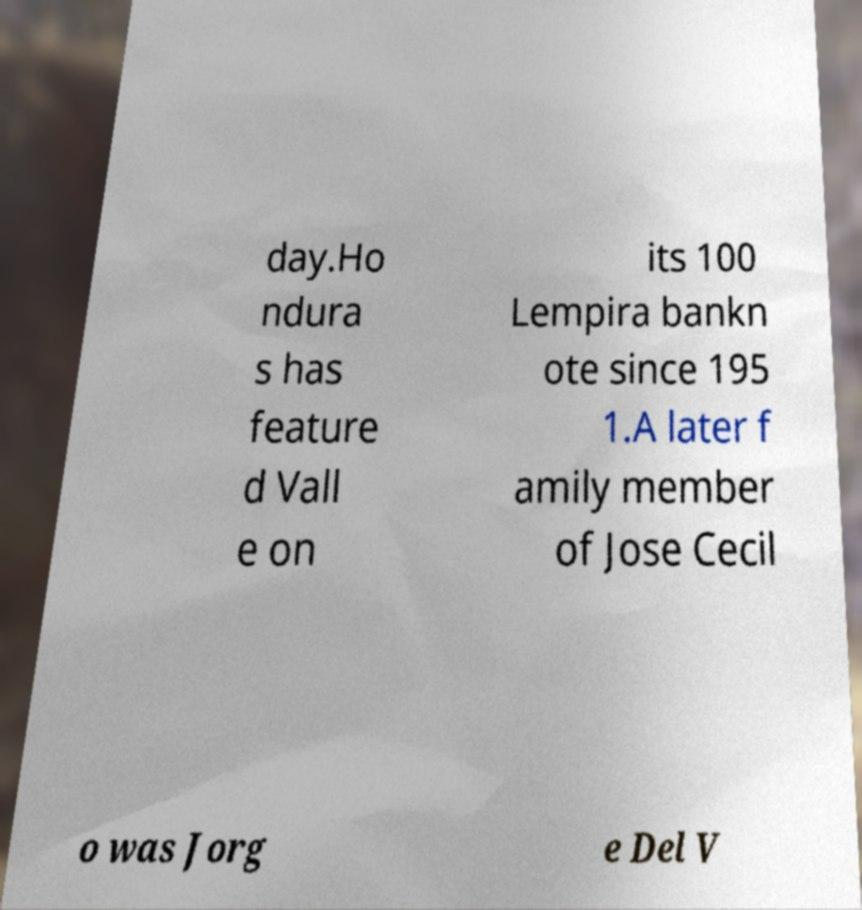Can you read and provide the text displayed in the image?This photo seems to have some interesting text. Can you extract and type it out for me? day.Ho ndura s has feature d Vall e on its 100 Lempira bankn ote since 195 1.A later f amily member of Jose Cecil o was Jorg e Del V 